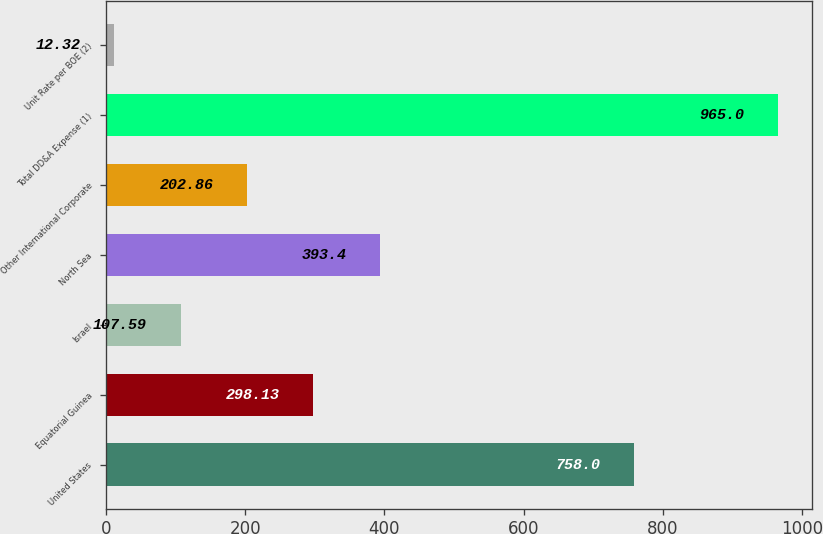Convert chart to OTSL. <chart><loc_0><loc_0><loc_500><loc_500><bar_chart><fcel>United States<fcel>Equatorial Guinea<fcel>Israel<fcel>North Sea<fcel>Other International Corporate<fcel>Total DD&A Expense (1)<fcel>Unit Rate per BOE (2)<nl><fcel>758<fcel>298.13<fcel>107.59<fcel>393.4<fcel>202.86<fcel>965<fcel>12.32<nl></chart> 